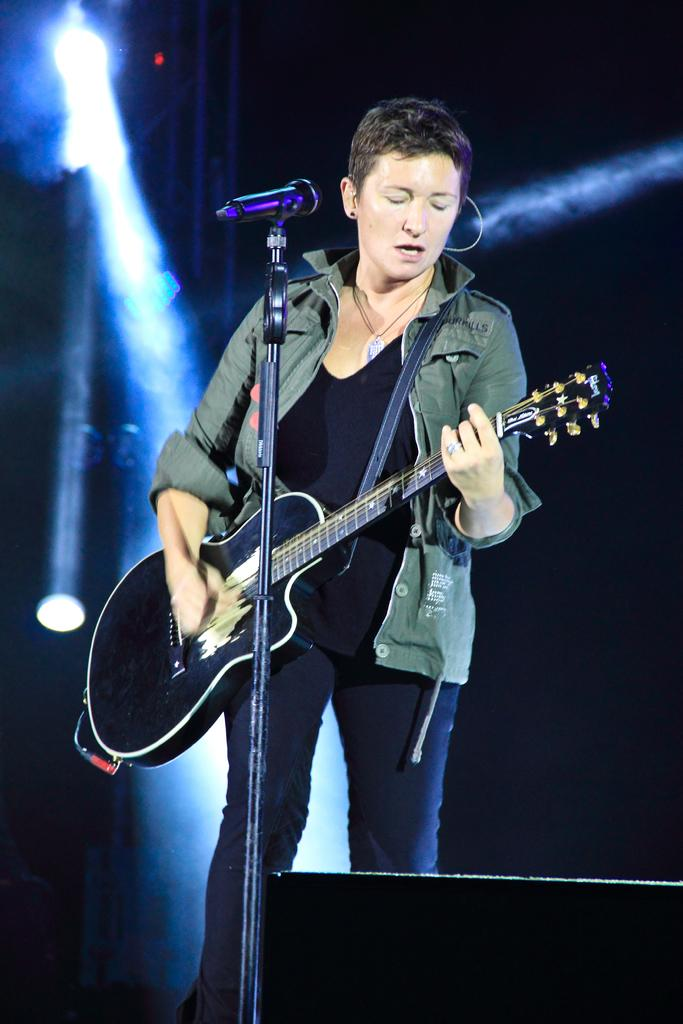Who is the main subject in the image? There is a woman in the image. What is the woman doing in the image? The woman is playing a musical instrument. What objects can be seen in the background of the image? There is a microphone and a light in the background. What type of fork can be seen on the table in the image? There is no fork present in the image. Is there a calculator visible on the stage in the image? There is no calculator visible in the image. 